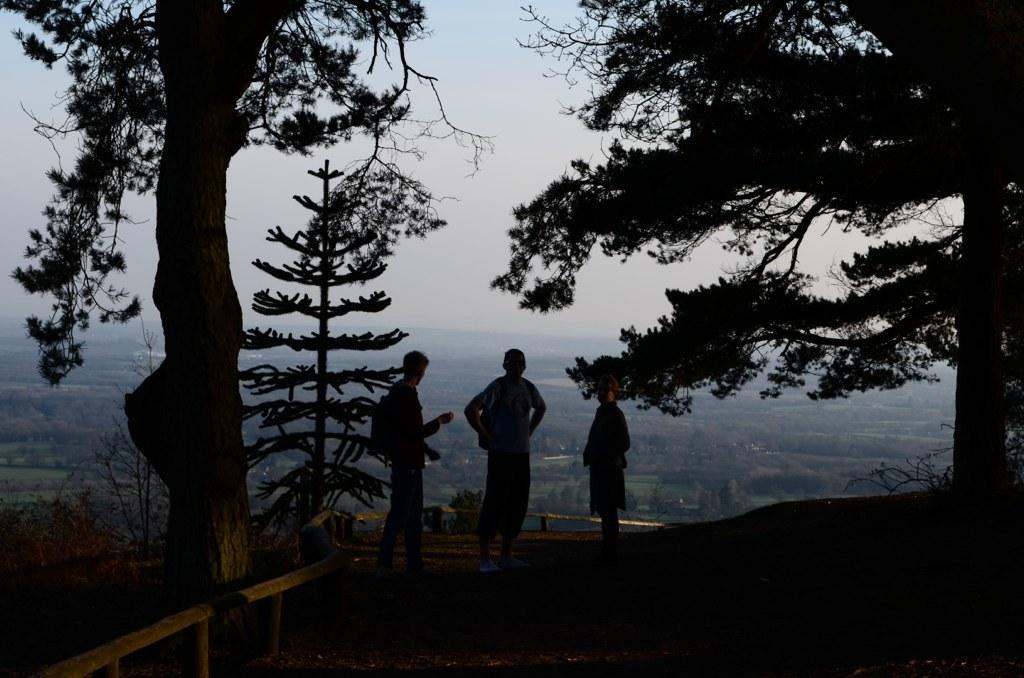Could you give a brief overview of what you see in this image? In the center of the image we can see people and there are trees. In the background there are hills and sky. On the left there is a fence. 